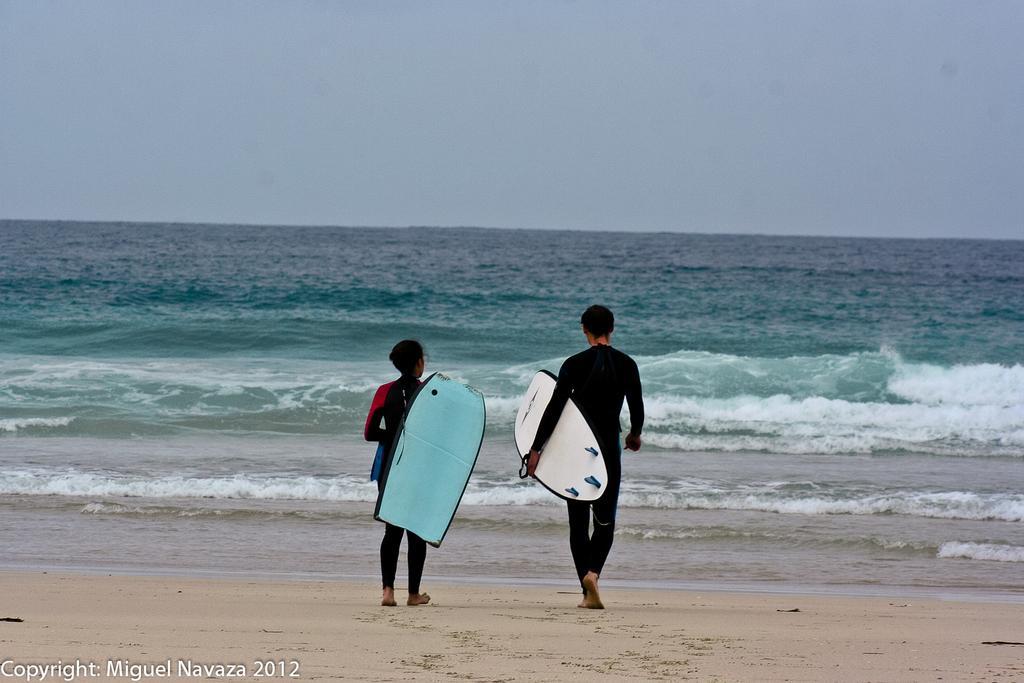How would you summarize this image in a sentence or two? A man and a woman holding surfing board and walking into the sea. In the background there is a sky. Also on the floor there is sand. 